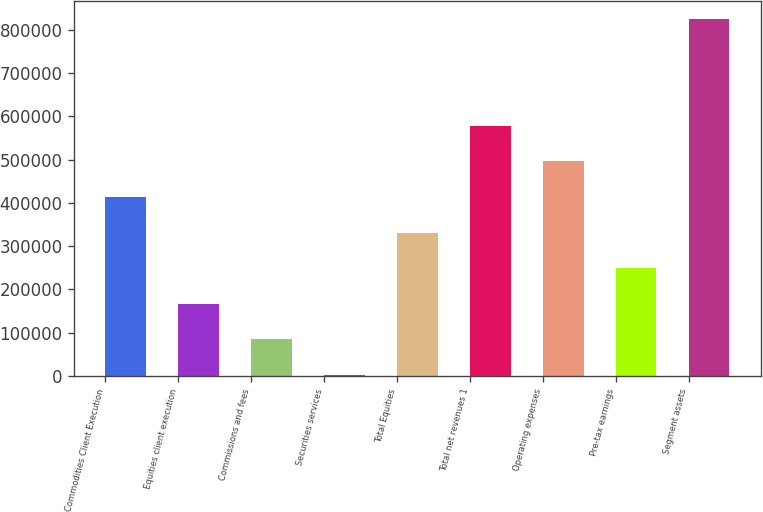<chart> <loc_0><loc_0><loc_500><loc_500><bar_chart><fcel>Commodities Client Execution<fcel>Equities client execution<fcel>Commissions and fees<fcel>Securities services<fcel>Total Equities<fcel>Total net revenues 1<fcel>Operating expenses<fcel>Pre-tax earnings<fcel>Segment assets<nl><fcel>413741<fcel>166688<fcel>84337<fcel>1986<fcel>331390<fcel>578443<fcel>496092<fcel>249039<fcel>825496<nl></chart> 